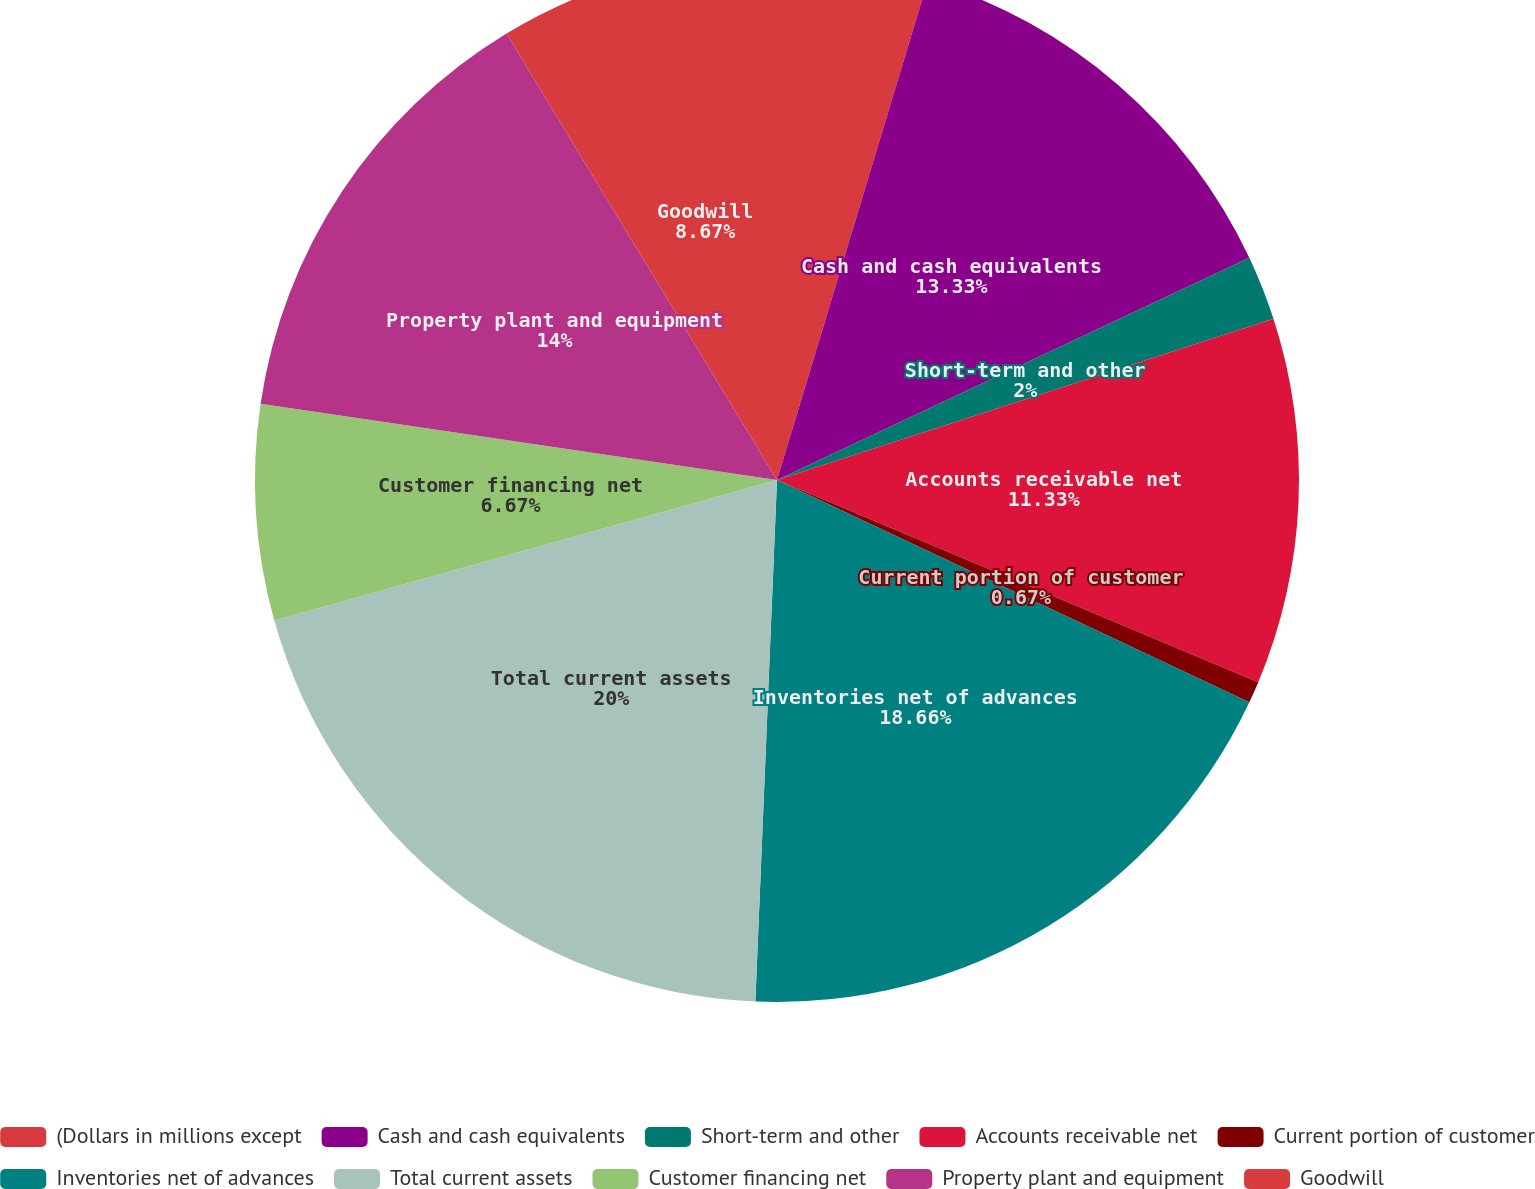<chart> <loc_0><loc_0><loc_500><loc_500><pie_chart><fcel>(Dollars in millions except<fcel>Cash and cash equivalents<fcel>Short-term and other<fcel>Accounts receivable net<fcel>Current portion of customer<fcel>Inventories net of advances<fcel>Total current assets<fcel>Customer financing net<fcel>Property plant and equipment<fcel>Goodwill<nl><fcel>4.67%<fcel>13.33%<fcel>2.0%<fcel>11.33%<fcel>0.67%<fcel>18.66%<fcel>20.0%<fcel>6.67%<fcel>14.0%<fcel>8.67%<nl></chart> 